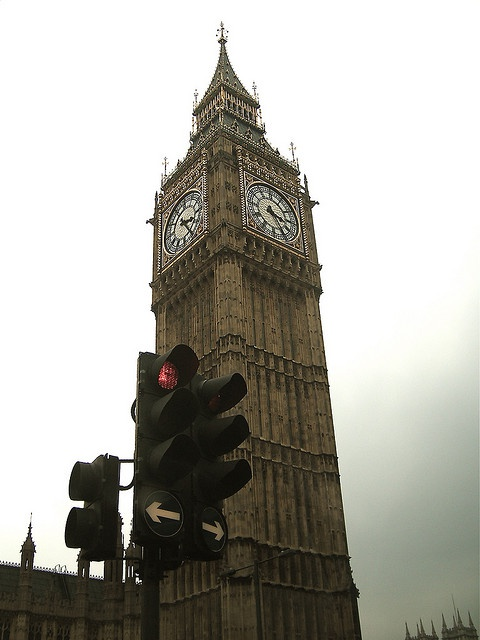Describe the objects in this image and their specific colors. I can see traffic light in white, black, and gray tones, traffic light in white, black, and gray tones, clock in white, black, gray, darkgray, and ivory tones, and clock in white, black, darkgray, gray, and ivory tones in this image. 